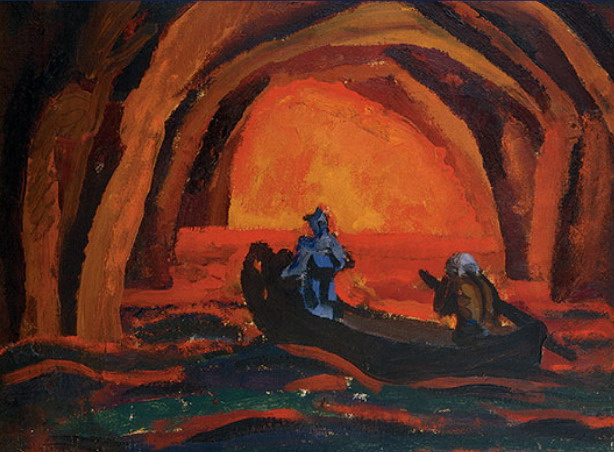What might be the significance of the cave setting in this artwork? Caves often symbolize exploration into the unknown or a journey into the inner self. In this painting, the cave can be interpreted as a metaphor for a spiritual or psychological exploration. The vivid and dramatic lighting enhances this metaphor, suggesting a transformative experience or pivotal moment occurring within the protected, yet mysterious, confines of the cave. 